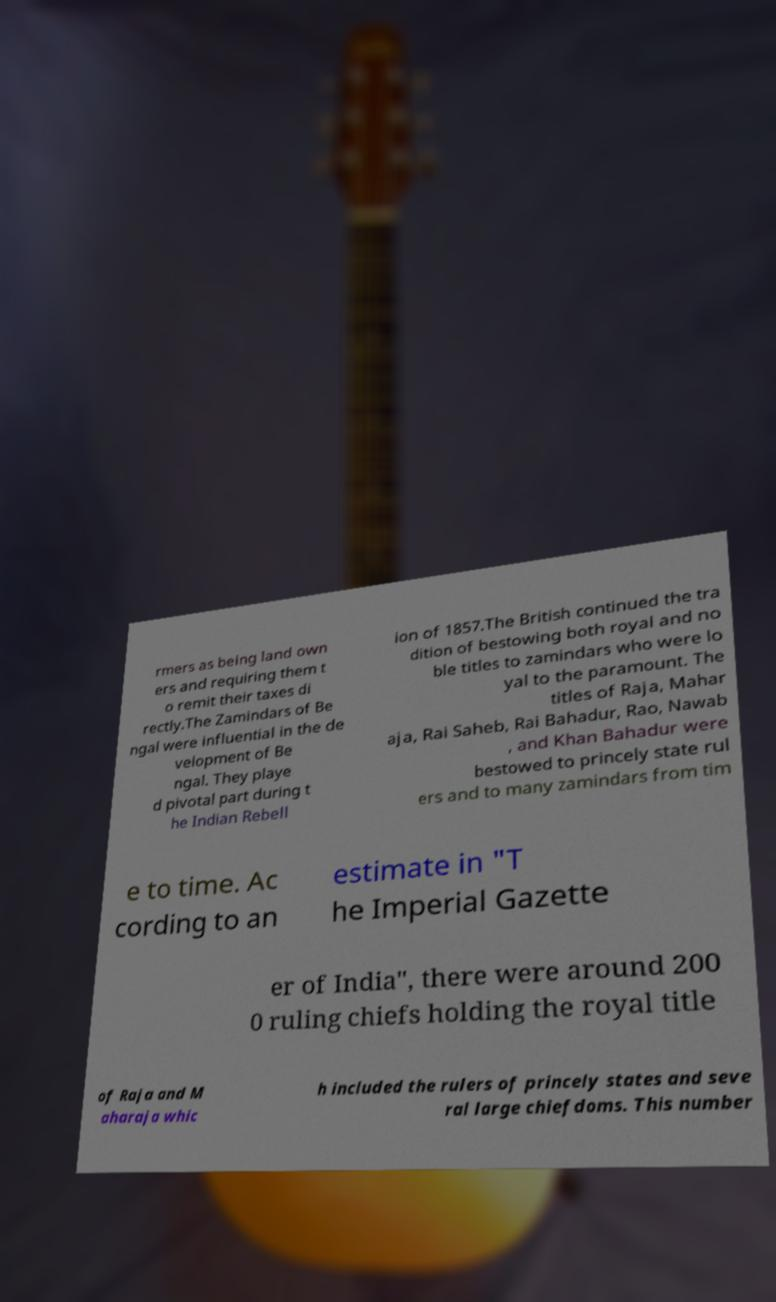Please identify and transcribe the text found in this image. rmers as being land own ers and requiring them t o remit their taxes di rectly.The Zamindars of Be ngal were influential in the de velopment of Be ngal. They playe d pivotal part during t he Indian Rebell ion of 1857.The British continued the tra dition of bestowing both royal and no ble titles to zamindars who were lo yal to the paramount. The titles of Raja, Mahar aja, Rai Saheb, Rai Bahadur, Rao, Nawab , and Khan Bahadur were bestowed to princely state rul ers and to many zamindars from tim e to time. Ac cording to an estimate in "T he Imperial Gazette er of India", there were around 200 0 ruling chiefs holding the royal title of Raja and M aharaja whic h included the rulers of princely states and seve ral large chiefdoms. This number 